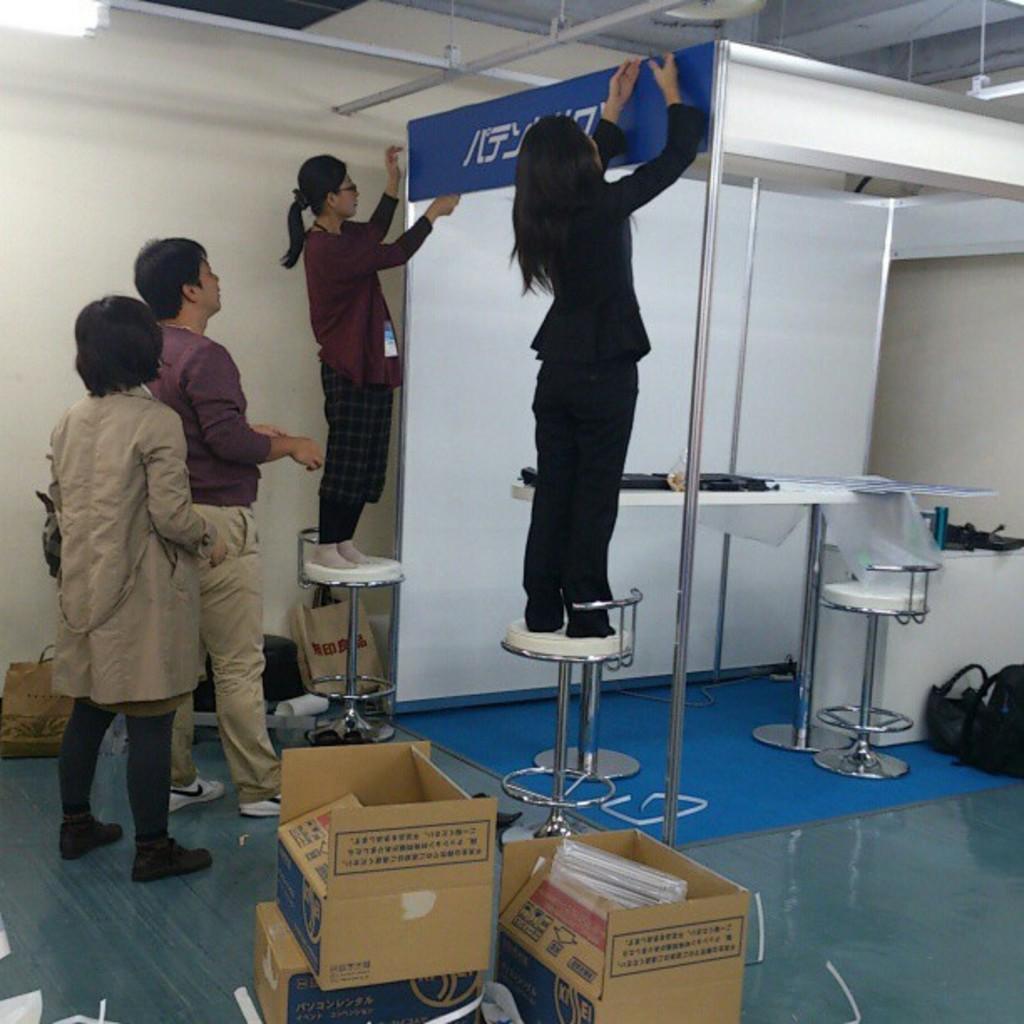Could you give a brief overview of what you see in this image? In this image we can see there are two girls standing on the chairs and adjusting a board, behind them there are two persons standing on the floor. On the floor there are few cotton boxes and some other objects placed. In the background there is a wall. 